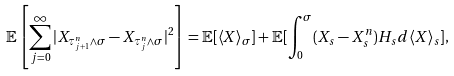<formula> <loc_0><loc_0><loc_500><loc_500>\mathbb { E } \left [ \sum _ { j = 0 } ^ { \infty } | X _ { \tau ^ { n } _ { j + 1 } \wedge \sigma } - X _ { \tau ^ { n } _ { j } \wedge \sigma } | ^ { 2 } \right ] = \mathbb { E } [ \langle X \rangle _ { \sigma } ] + \mathbb { E } [ \int _ { 0 } ^ { \sigma } ( X _ { s } - X ^ { n } _ { s } ) H _ { s } d \langle X \rangle _ { s } ] ,</formula> 